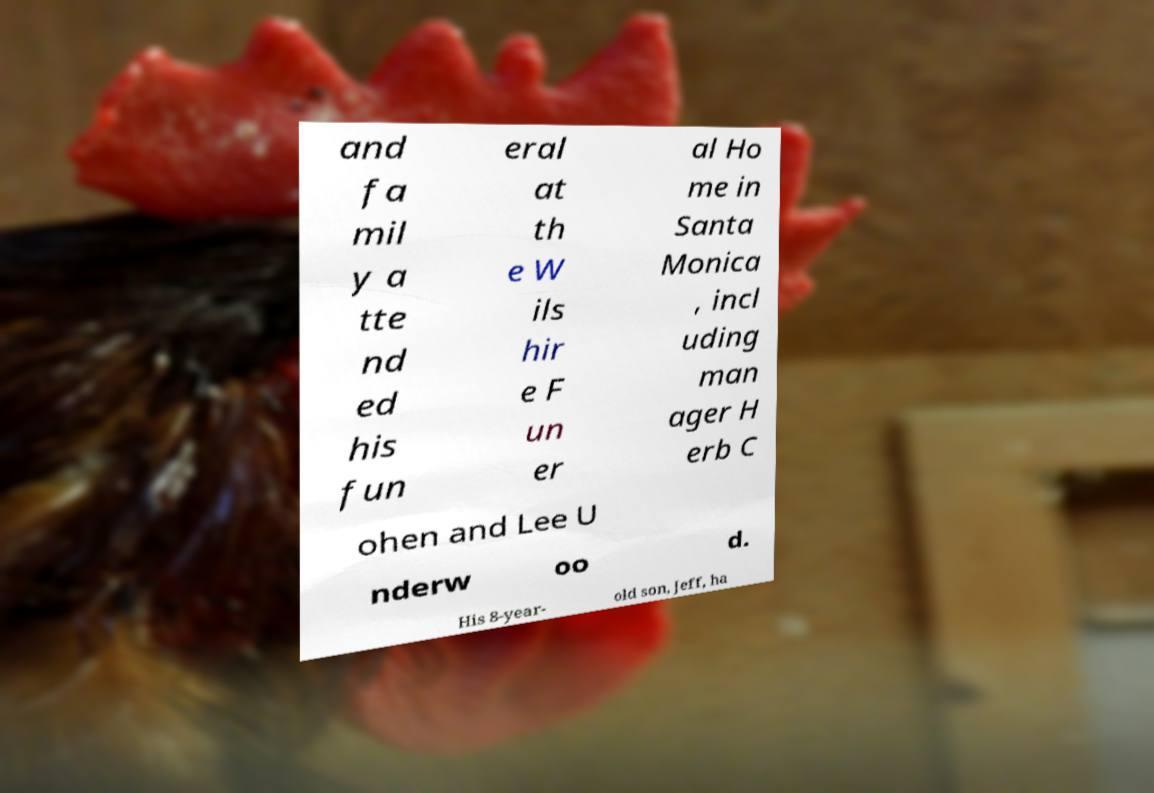Could you assist in decoding the text presented in this image and type it out clearly? and fa mil y a tte nd ed his fun eral at th e W ils hir e F un er al Ho me in Santa Monica , incl uding man ager H erb C ohen and Lee U nderw oo d. His 8-year- old son, Jeff, ha 